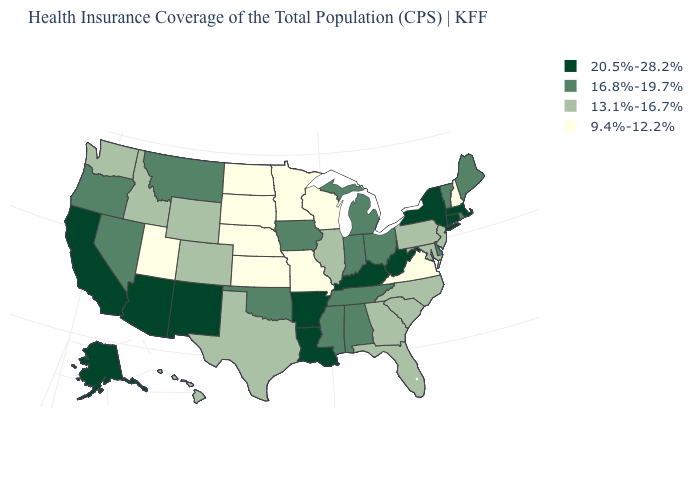What is the value of Oklahoma?
Be succinct. 16.8%-19.7%. How many symbols are there in the legend?
Keep it brief. 4. What is the value of New Hampshire?
Keep it brief. 9.4%-12.2%. Name the states that have a value in the range 13.1%-16.7%?
Quick response, please. Colorado, Florida, Georgia, Hawaii, Idaho, Illinois, Maryland, New Jersey, North Carolina, Pennsylvania, South Carolina, Texas, Washington, Wyoming. Name the states that have a value in the range 20.5%-28.2%?
Short answer required. Alaska, Arizona, Arkansas, California, Connecticut, Kentucky, Louisiana, Massachusetts, New Mexico, New York, West Virginia. What is the lowest value in the Northeast?
Be succinct. 9.4%-12.2%. Name the states that have a value in the range 13.1%-16.7%?
Give a very brief answer. Colorado, Florida, Georgia, Hawaii, Idaho, Illinois, Maryland, New Jersey, North Carolina, Pennsylvania, South Carolina, Texas, Washington, Wyoming. Name the states that have a value in the range 16.8%-19.7%?
Write a very short answer. Alabama, Delaware, Indiana, Iowa, Maine, Michigan, Mississippi, Montana, Nevada, Ohio, Oklahoma, Oregon, Rhode Island, Tennessee, Vermont. Name the states that have a value in the range 20.5%-28.2%?
Give a very brief answer. Alaska, Arizona, Arkansas, California, Connecticut, Kentucky, Louisiana, Massachusetts, New Mexico, New York, West Virginia. Name the states that have a value in the range 20.5%-28.2%?
Quick response, please. Alaska, Arizona, Arkansas, California, Connecticut, Kentucky, Louisiana, Massachusetts, New Mexico, New York, West Virginia. Which states have the lowest value in the Northeast?
Quick response, please. New Hampshire. What is the highest value in states that border Arkansas?
Keep it brief. 20.5%-28.2%. What is the lowest value in states that border Nevada?
Quick response, please. 9.4%-12.2%. Does Utah have the lowest value in the USA?
Give a very brief answer. Yes. How many symbols are there in the legend?
Answer briefly. 4. 